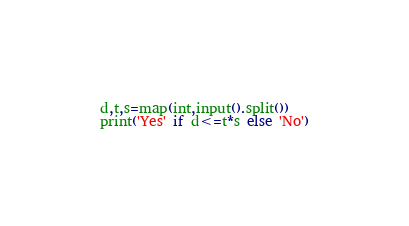Convert code to text. <code><loc_0><loc_0><loc_500><loc_500><_Python_>d,t,s=map(int,input().split())
print('Yes' if d<=t*s else 'No')</code> 